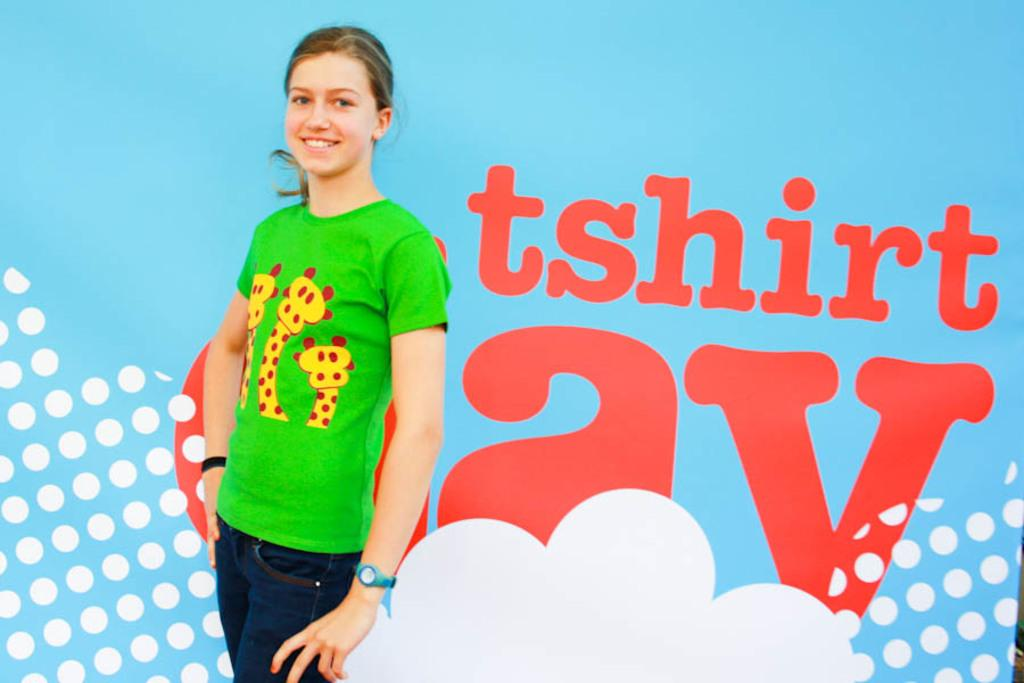Who is present in the image? There is a woman in the image. What is the woman doing in the image? The woman is standing in the image. What is the woman's facial expression in the image? The woman is smiling in the image. What can be seen in the background of the image? There is a hoarding visible in the background of the image. How many baskets can be seen hanging from the woman's wings in the image? There are no baskets or wings present in the image; it features a woman standing and smiling. 